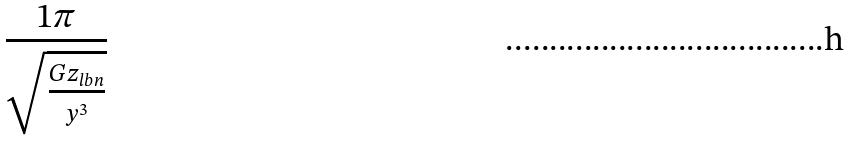Convert formula to latex. <formula><loc_0><loc_0><loc_500><loc_500>\frac { 1 \pi } { \sqrt { \frac { G z _ { l b n } } { y ^ { 3 } } } }</formula> 